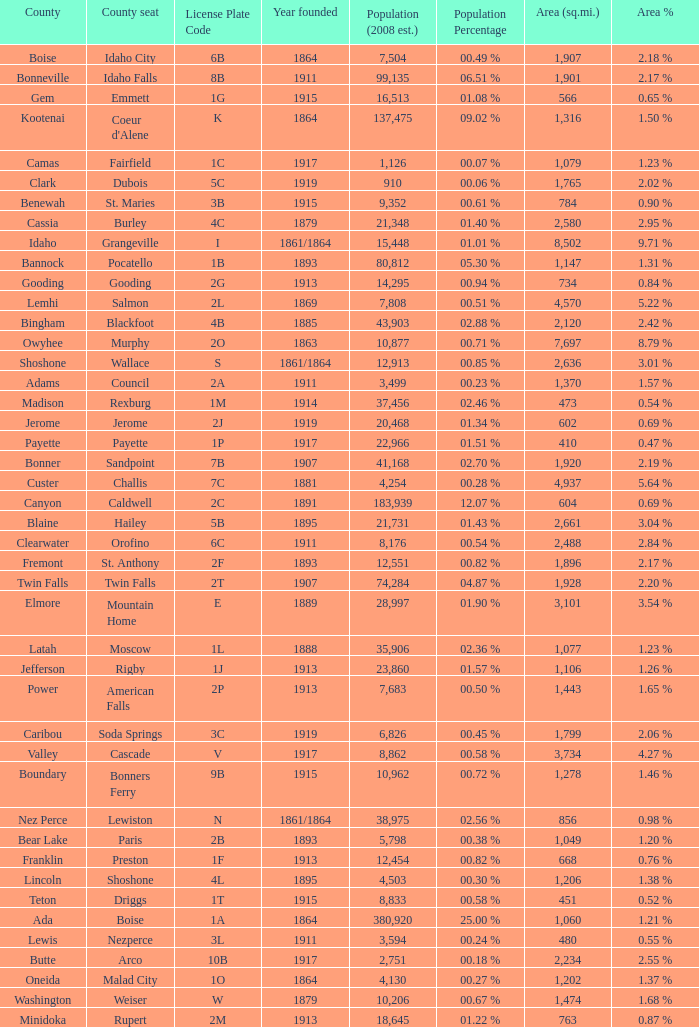What is the country seat for the license plate code 5c? Dubois. 